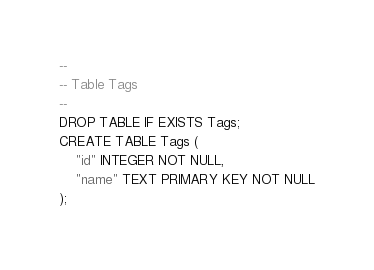Convert code to text. <code><loc_0><loc_0><loc_500><loc_500><_SQL_>--
-- Table Tags
--
DROP TABLE IF EXISTS Tags;
CREATE TABLE Tags (
    "id" INTEGER NOT NULL,
    "name" TEXT PRIMARY KEY NOT NULL
);
</code> 